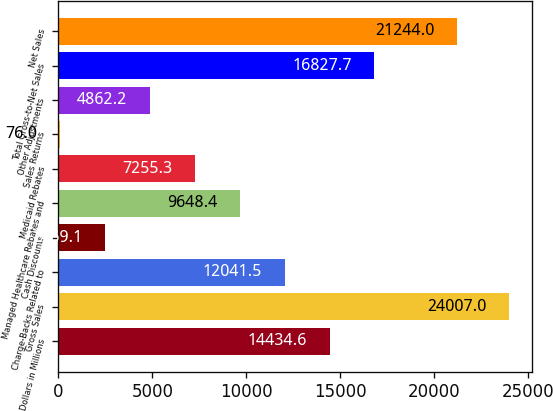Convert chart. <chart><loc_0><loc_0><loc_500><loc_500><bar_chart><fcel>Dollars in Millions<fcel>Gross Sales<fcel>Charge-Backs Related to<fcel>Cash Discounts<fcel>Managed Healthcare Rebates and<fcel>Medicaid Rebates<fcel>Sales Returns<fcel>Other Adjustments<fcel>Total Gross-to-Net Sales<fcel>Net Sales<nl><fcel>14434.6<fcel>24007<fcel>12041.5<fcel>2469.1<fcel>9648.4<fcel>7255.3<fcel>76<fcel>4862.2<fcel>16827.7<fcel>21244<nl></chart> 